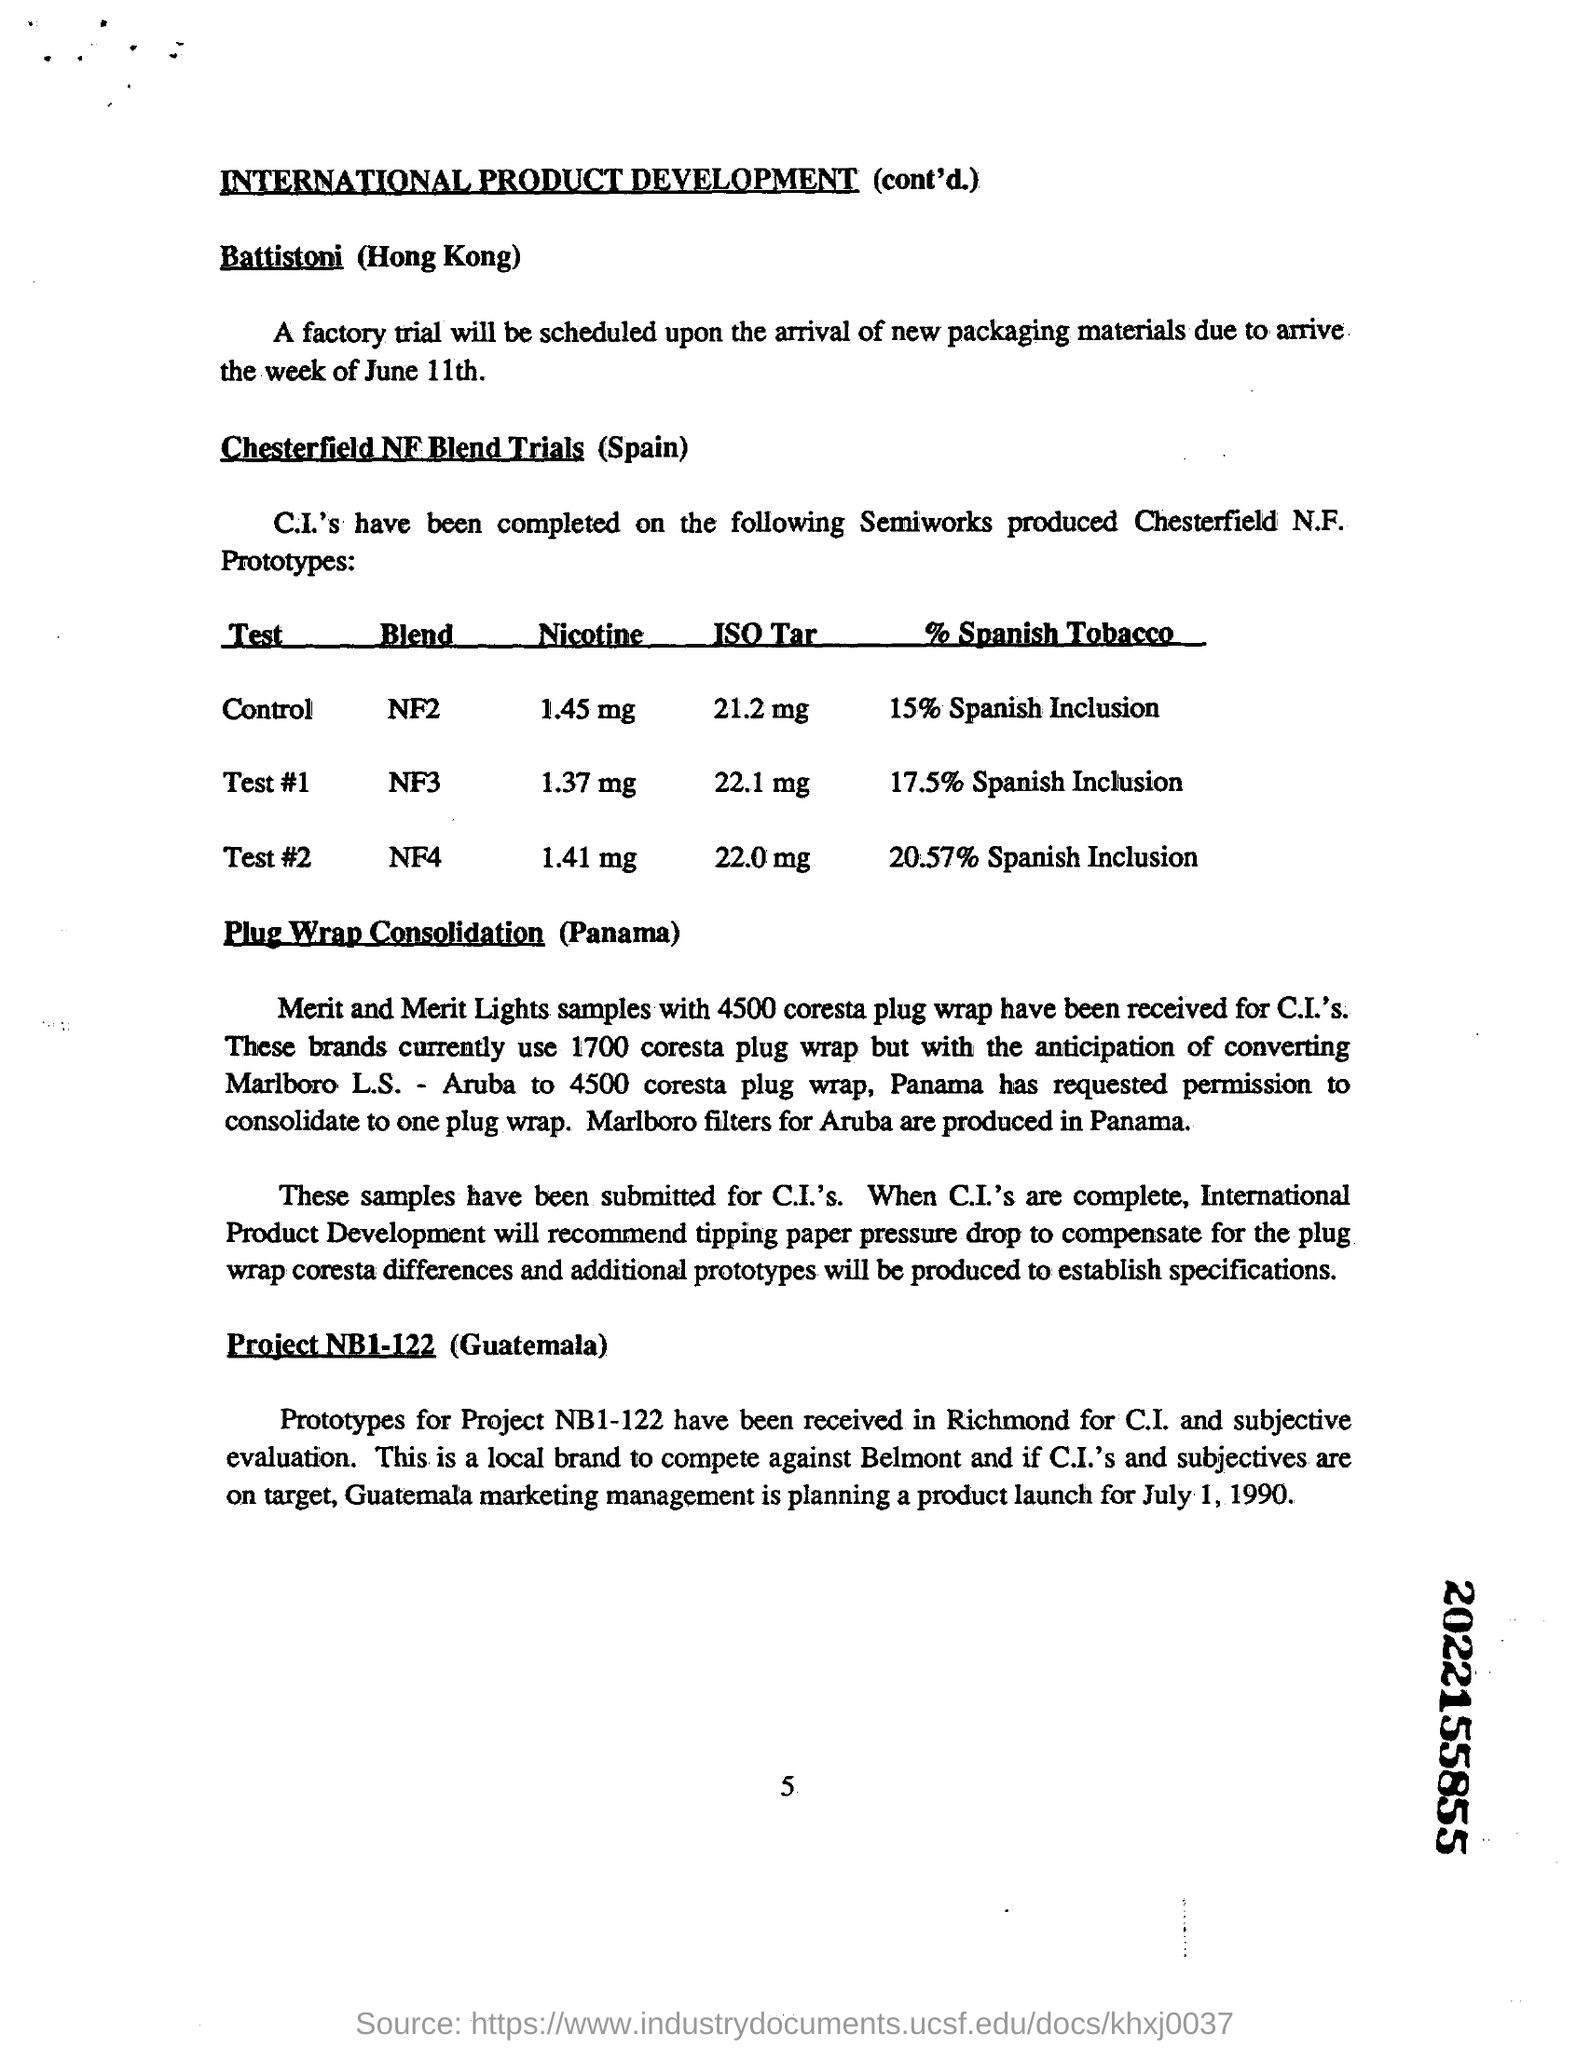Specify some key components in this picture. The launch of the product was planned by the marketing management team of Guatemala on July 1, 1990. Approximately 17.5% of the tobacco used in Test #1 is Spanish. The first sub-heading in the document is 'Battistoni (Hong Kong).'. 